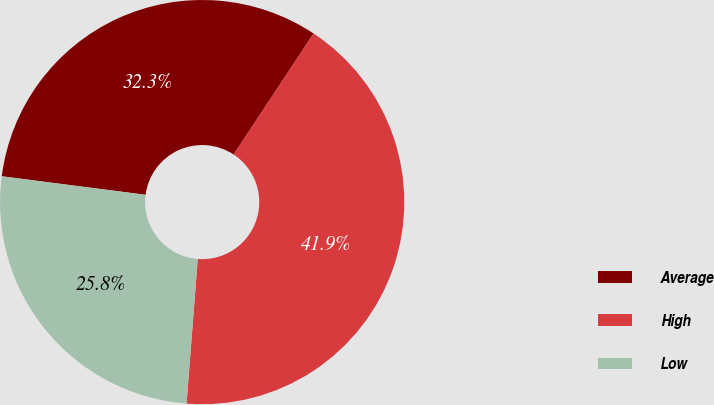Convert chart. <chart><loc_0><loc_0><loc_500><loc_500><pie_chart><fcel>Average<fcel>High<fcel>Low<nl><fcel>32.26%<fcel>41.94%<fcel>25.81%<nl></chart> 